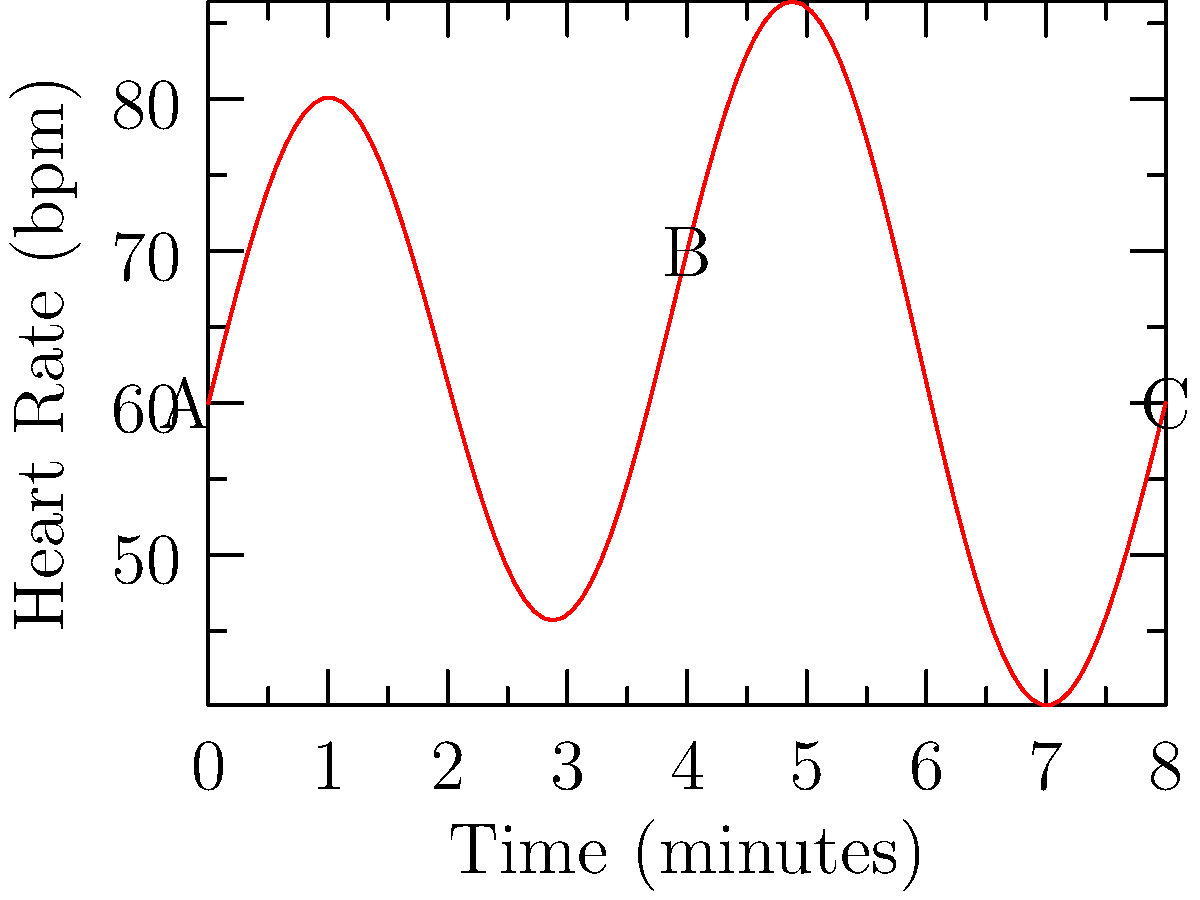The graph above shows a musician's heart rate (in beats per minute) during an 8-minute performance. Let $f(t)$ represent the heart rate function. At which point (A, B, or C) is the rate of change of the musician's heart rate the greatest, and what is the approximate value of $f'(t)$ at this point? To solve this problem, we need to analyze the derivative of the function at points A, B, and C:

1) Point A (t = 0):
   The slope is positive and steep, indicating a high positive rate of change.

2) Point B (t = 4):
   The slope is close to zero, indicating little to no rate of change.

3) Point C (t = 8):
   The slope is negative but not as steep as at point A.

The greatest rate of change (in absolute value) is at point A, where the graph has the steepest slope.

To estimate $f'(0)$:
1) Choose two nearby points: (0, 60) and (1, ~75)
2) Calculate the slope: $\frac{\Delta y}{\Delta x} = \frac{75 - 60}{1 - 0} = 15$

Therefore, $f'(0) \approx 15$ beats per minute per minute.
Answer: Point A, $f'(0) \approx 15$ bpm/min 